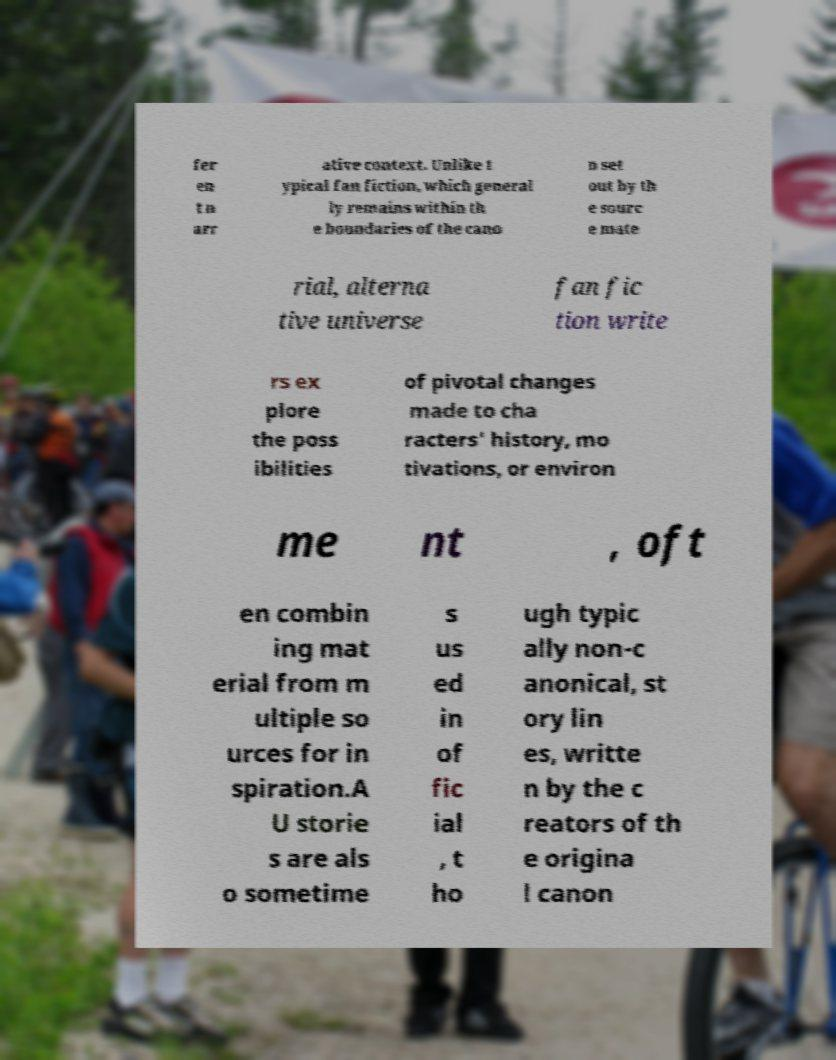There's text embedded in this image that I need extracted. Can you transcribe it verbatim? fer en t n arr ative context. Unlike t ypical fan fiction, which general ly remains within th e boundaries of the cano n set out by th e sourc e mate rial, alterna tive universe fan fic tion write rs ex plore the poss ibilities of pivotal changes made to cha racters' history, mo tivations, or environ me nt , oft en combin ing mat erial from m ultiple so urces for in spiration.A U storie s are als o sometime s us ed in of fic ial , t ho ugh typic ally non-c anonical, st ory lin es, writte n by the c reators of th e origina l canon 